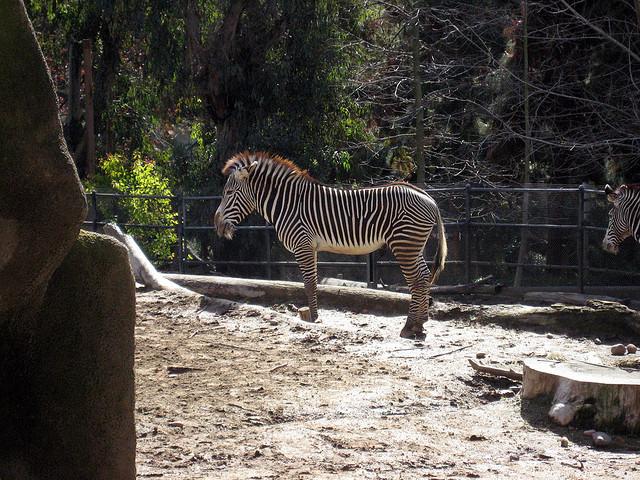How many different kinds of animals are in the picture?
Answer briefly. 1. Is the zebra malnourished?
Be succinct. No. Does this zebra have any grass to eat?
Short answer required. No. Are these zebras in the wild?
Keep it brief. No. Is he grazing?
Give a very brief answer. No. 